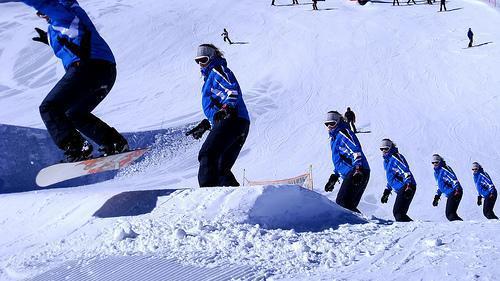How many skiers can you see with black gloves?
Give a very brief answer. 6. How many women in blue jackets are shown?
Give a very brief answer. 6. How many images of the snowboarder show the snowboarder in the air?
Give a very brief answer. 1. How many people are fully visible in the background?
Give a very brief answer. 3. 